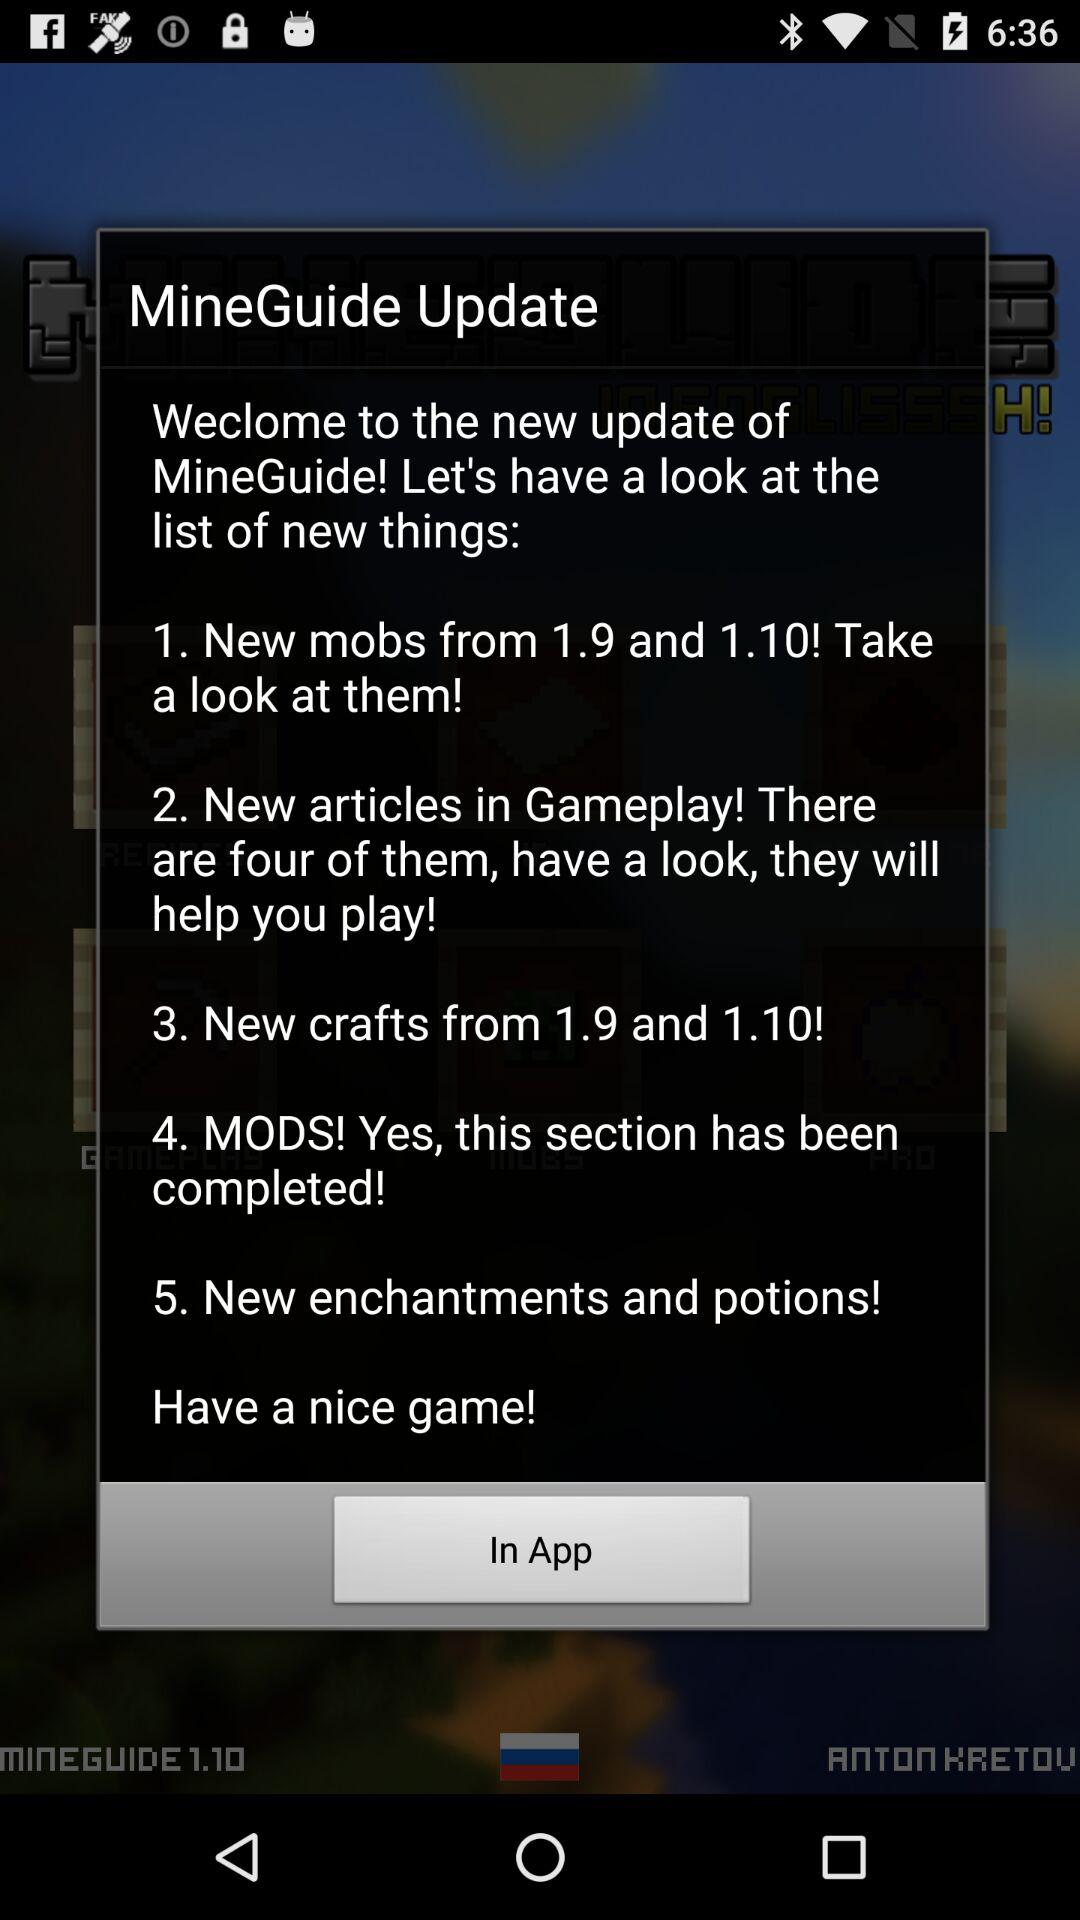How many new articles are there in the Gameplay section?
Answer the question using a single word or phrase. 4 